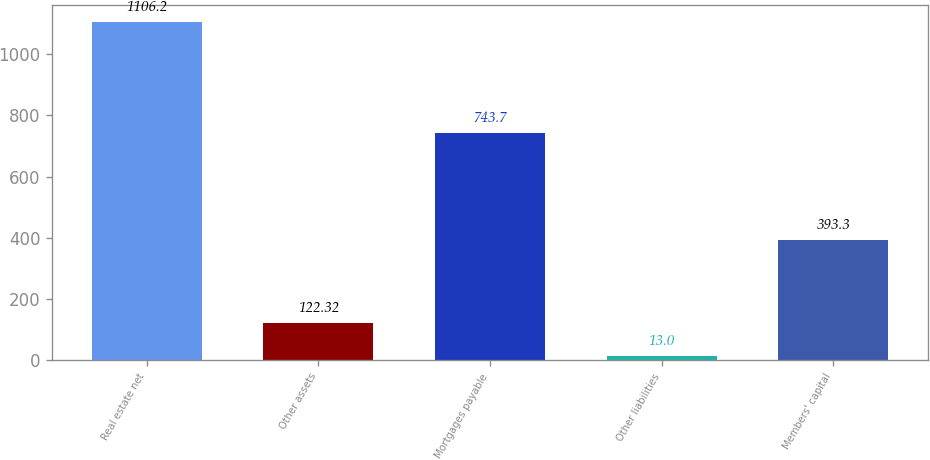<chart> <loc_0><loc_0><loc_500><loc_500><bar_chart><fcel>Real estate net<fcel>Other assets<fcel>Mortgages payable<fcel>Other liabilities<fcel>Members' capital<nl><fcel>1106.2<fcel>122.32<fcel>743.7<fcel>13<fcel>393.3<nl></chart> 